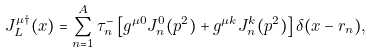Convert formula to latex. <formula><loc_0><loc_0><loc_500><loc_500>J _ { L } ^ { \mu \dagger } ( x ) = \sum _ { n = 1 } ^ { A } \tau _ { n } ^ { - } \left [ g ^ { \mu 0 } J _ { n } ^ { 0 } ( p ^ { 2 } ) + g ^ { \mu k } J _ { n } ^ { k } ( p ^ { 2 } ) \right ] \delta ( x - r _ { n } ) ,</formula> 